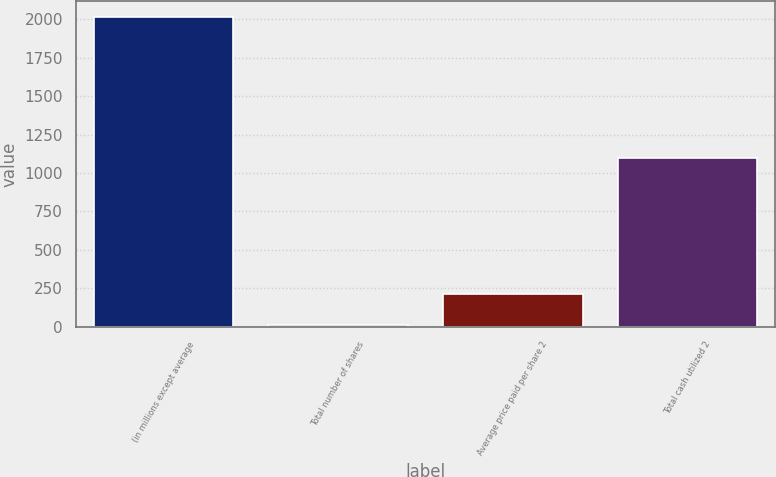<chart> <loc_0><loc_0><loc_500><loc_500><bar_chart><fcel>(in millions except average<fcel>Total number of shares<fcel>Average price paid per share 2<fcel>Total cash utilized 2<nl><fcel>2016<fcel>9.7<fcel>210.33<fcel>1097<nl></chart> 